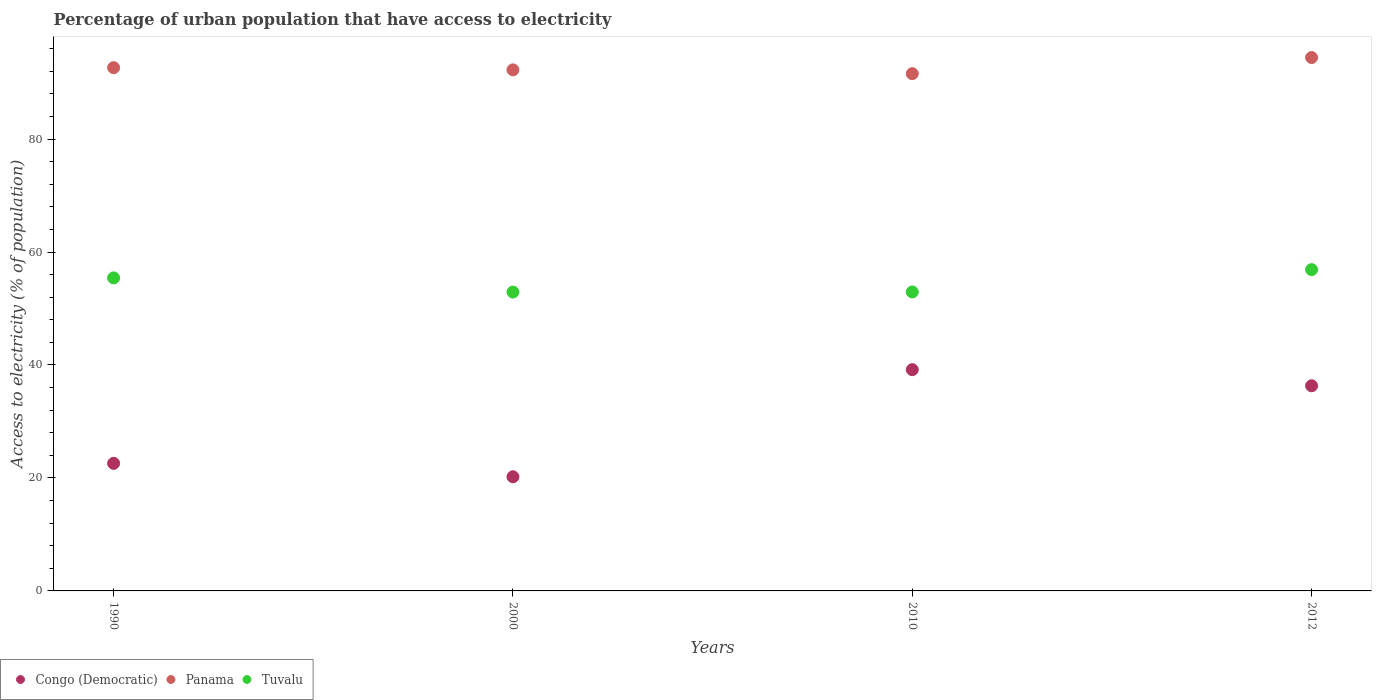What is the percentage of urban population that have access to electricity in Tuvalu in 2000?
Provide a short and direct response. 52.91. Across all years, what is the maximum percentage of urban population that have access to electricity in Congo (Democratic)?
Your response must be concise. 39.17. Across all years, what is the minimum percentage of urban population that have access to electricity in Tuvalu?
Offer a very short reply. 52.91. In which year was the percentage of urban population that have access to electricity in Tuvalu minimum?
Make the answer very short. 2000. What is the total percentage of urban population that have access to electricity in Tuvalu in the graph?
Your response must be concise. 218.14. What is the difference between the percentage of urban population that have access to electricity in Tuvalu in 1990 and that in 2000?
Keep it short and to the point. 2.51. What is the difference between the percentage of urban population that have access to electricity in Panama in 2000 and the percentage of urban population that have access to electricity in Congo (Democratic) in 2012?
Make the answer very short. 55.93. What is the average percentage of urban population that have access to electricity in Congo (Democratic) per year?
Offer a very short reply. 29.57. In the year 1990, what is the difference between the percentage of urban population that have access to electricity in Tuvalu and percentage of urban population that have access to electricity in Congo (Democratic)?
Your answer should be very brief. 32.84. What is the ratio of the percentage of urban population that have access to electricity in Panama in 1990 to that in 2000?
Your answer should be very brief. 1. What is the difference between the highest and the second highest percentage of urban population that have access to electricity in Congo (Democratic)?
Give a very brief answer. 2.86. What is the difference between the highest and the lowest percentage of urban population that have access to electricity in Panama?
Make the answer very short. 2.86. In how many years, is the percentage of urban population that have access to electricity in Tuvalu greater than the average percentage of urban population that have access to electricity in Tuvalu taken over all years?
Offer a very short reply. 2. Does the percentage of urban population that have access to electricity in Congo (Democratic) monotonically increase over the years?
Your answer should be very brief. No. How many dotlines are there?
Provide a succinct answer. 3. What is the difference between two consecutive major ticks on the Y-axis?
Give a very brief answer. 20. Are the values on the major ticks of Y-axis written in scientific E-notation?
Your response must be concise. No. Does the graph contain any zero values?
Make the answer very short. No. Where does the legend appear in the graph?
Provide a succinct answer. Bottom left. How many legend labels are there?
Offer a terse response. 3. How are the legend labels stacked?
Give a very brief answer. Horizontal. What is the title of the graph?
Make the answer very short. Percentage of urban population that have access to electricity. What is the label or title of the Y-axis?
Provide a succinct answer. Access to electricity (% of population). What is the Access to electricity (% of population) in Congo (Democratic) in 1990?
Your answer should be compact. 22.58. What is the Access to electricity (% of population) in Panama in 1990?
Make the answer very short. 92.63. What is the Access to electricity (% of population) in Tuvalu in 1990?
Your response must be concise. 55.42. What is the Access to electricity (% of population) of Congo (Democratic) in 2000?
Your response must be concise. 20.21. What is the Access to electricity (% of population) in Panama in 2000?
Provide a short and direct response. 92.25. What is the Access to electricity (% of population) of Tuvalu in 2000?
Offer a very short reply. 52.91. What is the Access to electricity (% of population) of Congo (Democratic) in 2010?
Provide a succinct answer. 39.17. What is the Access to electricity (% of population) of Panama in 2010?
Your answer should be compact. 91.57. What is the Access to electricity (% of population) of Tuvalu in 2010?
Offer a terse response. 52.93. What is the Access to electricity (% of population) of Congo (Democratic) in 2012?
Your response must be concise. 36.32. What is the Access to electricity (% of population) in Panama in 2012?
Provide a succinct answer. 94.43. What is the Access to electricity (% of population) in Tuvalu in 2012?
Provide a succinct answer. 56.88. Across all years, what is the maximum Access to electricity (% of population) in Congo (Democratic)?
Keep it short and to the point. 39.17. Across all years, what is the maximum Access to electricity (% of population) in Panama?
Ensure brevity in your answer.  94.43. Across all years, what is the maximum Access to electricity (% of population) in Tuvalu?
Give a very brief answer. 56.88. Across all years, what is the minimum Access to electricity (% of population) in Congo (Democratic)?
Offer a terse response. 20.21. Across all years, what is the minimum Access to electricity (% of population) in Panama?
Your answer should be compact. 91.57. Across all years, what is the minimum Access to electricity (% of population) in Tuvalu?
Provide a succinct answer. 52.91. What is the total Access to electricity (% of population) of Congo (Democratic) in the graph?
Provide a succinct answer. 118.29. What is the total Access to electricity (% of population) in Panama in the graph?
Your response must be concise. 370.88. What is the total Access to electricity (% of population) in Tuvalu in the graph?
Ensure brevity in your answer.  218.14. What is the difference between the Access to electricity (% of population) in Congo (Democratic) in 1990 and that in 2000?
Make the answer very short. 2.37. What is the difference between the Access to electricity (% of population) in Panama in 1990 and that in 2000?
Make the answer very short. 0.39. What is the difference between the Access to electricity (% of population) of Tuvalu in 1990 and that in 2000?
Make the answer very short. 2.51. What is the difference between the Access to electricity (% of population) in Congo (Democratic) in 1990 and that in 2010?
Provide a short and direct response. -16.59. What is the difference between the Access to electricity (% of population) in Panama in 1990 and that in 2010?
Your answer should be very brief. 1.06. What is the difference between the Access to electricity (% of population) in Tuvalu in 1990 and that in 2010?
Provide a short and direct response. 2.49. What is the difference between the Access to electricity (% of population) of Congo (Democratic) in 1990 and that in 2012?
Provide a short and direct response. -13.73. What is the difference between the Access to electricity (% of population) in Panama in 1990 and that in 2012?
Provide a short and direct response. -1.8. What is the difference between the Access to electricity (% of population) of Tuvalu in 1990 and that in 2012?
Make the answer very short. -1.46. What is the difference between the Access to electricity (% of population) of Congo (Democratic) in 2000 and that in 2010?
Your answer should be compact. -18.96. What is the difference between the Access to electricity (% of population) of Panama in 2000 and that in 2010?
Make the answer very short. 0.67. What is the difference between the Access to electricity (% of population) of Tuvalu in 2000 and that in 2010?
Offer a very short reply. -0.02. What is the difference between the Access to electricity (% of population) of Congo (Democratic) in 2000 and that in 2012?
Keep it short and to the point. -16.11. What is the difference between the Access to electricity (% of population) of Panama in 2000 and that in 2012?
Make the answer very short. -2.18. What is the difference between the Access to electricity (% of population) in Tuvalu in 2000 and that in 2012?
Keep it short and to the point. -3.97. What is the difference between the Access to electricity (% of population) of Congo (Democratic) in 2010 and that in 2012?
Your response must be concise. 2.86. What is the difference between the Access to electricity (% of population) of Panama in 2010 and that in 2012?
Offer a terse response. -2.86. What is the difference between the Access to electricity (% of population) in Tuvalu in 2010 and that in 2012?
Offer a very short reply. -3.95. What is the difference between the Access to electricity (% of population) of Congo (Democratic) in 1990 and the Access to electricity (% of population) of Panama in 2000?
Your answer should be very brief. -69.66. What is the difference between the Access to electricity (% of population) in Congo (Democratic) in 1990 and the Access to electricity (% of population) in Tuvalu in 2000?
Your response must be concise. -30.33. What is the difference between the Access to electricity (% of population) in Panama in 1990 and the Access to electricity (% of population) in Tuvalu in 2000?
Your response must be concise. 39.72. What is the difference between the Access to electricity (% of population) in Congo (Democratic) in 1990 and the Access to electricity (% of population) in Panama in 2010?
Your response must be concise. -68.99. What is the difference between the Access to electricity (% of population) in Congo (Democratic) in 1990 and the Access to electricity (% of population) in Tuvalu in 2010?
Give a very brief answer. -30.35. What is the difference between the Access to electricity (% of population) of Panama in 1990 and the Access to electricity (% of population) of Tuvalu in 2010?
Offer a terse response. 39.7. What is the difference between the Access to electricity (% of population) in Congo (Democratic) in 1990 and the Access to electricity (% of population) in Panama in 2012?
Provide a succinct answer. -71.85. What is the difference between the Access to electricity (% of population) of Congo (Democratic) in 1990 and the Access to electricity (% of population) of Tuvalu in 2012?
Offer a terse response. -34.3. What is the difference between the Access to electricity (% of population) of Panama in 1990 and the Access to electricity (% of population) of Tuvalu in 2012?
Your response must be concise. 35.75. What is the difference between the Access to electricity (% of population) of Congo (Democratic) in 2000 and the Access to electricity (% of population) of Panama in 2010?
Give a very brief answer. -71.36. What is the difference between the Access to electricity (% of population) of Congo (Democratic) in 2000 and the Access to electricity (% of population) of Tuvalu in 2010?
Keep it short and to the point. -32.72. What is the difference between the Access to electricity (% of population) in Panama in 2000 and the Access to electricity (% of population) in Tuvalu in 2010?
Offer a very short reply. 39.32. What is the difference between the Access to electricity (% of population) in Congo (Democratic) in 2000 and the Access to electricity (% of population) in Panama in 2012?
Your answer should be very brief. -74.22. What is the difference between the Access to electricity (% of population) in Congo (Democratic) in 2000 and the Access to electricity (% of population) in Tuvalu in 2012?
Give a very brief answer. -36.67. What is the difference between the Access to electricity (% of population) in Panama in 2000 and the Access to electricity (% of population) in Tuvalu in 2012?
Your answer should be compact. 35.37. What is the difference between the Access to electricity (% of population) in Congo (Democratic) in 2010 and the Access to electricity (% of population) in Panama in 2012?
Keep it short and to the point. -55.26. What is the difference between the Access to electricity (% of population) of Congo (Democratic) in 2010 and the Access to electricity (% of population) of Tuvalu in 2012?
Make the answer very short. -17.71. What is the difference between the Access to electricity (% of population) of Panama in 2010 and the Access to electricity (% of population) of Tuvalu in 2012?
Provide a short and direct response. 34.69. What is the average Access to electricity (% of population) in Congo (Democratic) per year?
Your answer should be very brief. 29.57. What is the average Access to electricity (% of population) of Panama per year?
Provide a short and direct response. 92.72. What is the average Access to electricity (% of population) in Tuvalu per year?
Ensure brevity in your answer.  54.54. In the year 1990, what is the difference between the Access to electricity (% of population) of Congo (Democratic) and Access to electricity (% of population) of Panama?
Offer a terse response. -70.05. In the year 1990, what is the difference between the Access to electricity (% of population) of Congo (Democratic) and Access to electricity (% of population) of Tuvalu?
Ensure brevity in your answer.  -32.84. In the year 1990, what is the difference between the Access to electricity (% of population) of Panama and Access to electricity (% of population) of Tuvalu?
Make the answer very short. 37.21. In the year 2000, what is the difference between the Access to electricity (% of population) in Congo (Democratic) and Access to electricity (% of population) in Panama?
Offer a terse response. -72.04. In the year 2000, what is the difference between the Access to electricity (% of population) of Congo (Democratic) and Access to electricity (% of population) of Tuvalu?
Ensure brevity in your answer.  -32.7. In the year 2000, what is the difference between the Access to electricity (% of population) of Panama and Access to electricity (% of population) of Tuvalu?
Ensure brevity in your answer.  39.34. In the year 2010, what is the difference between the Access to electricity (% of population) of Congo (Democratic) and Access to electricity (% of population) of Panama?
Provide a short and direct response. -52.4. In the year 2010, what is the difference between the Access to electricity (% of population) of Congo (Democratic) and Access to electricity (% of population) of Tuvalu?
Offer a very short reply. -13.76. In the year 2010, what is the difference between the Access to electricity (% of population) of Panama and Access to electricity (% of population) of Tuvalu?
Provide a short and direct response. 38.64. In the year 2012, what is the difference between the Access to electricity (% of population) of Congo (Democratic) and Access to electricity (% of population) of Panama?
Ensure brevity in your answer.  -58.11. In the year 2012, what is the difference between the Access to electricity (% of population) in Congo (Democratic) and Access to electricity (% of population) in Tuvalu?
Offer a very short reply. -20.56. In the year 2012, what is the difference between the Access to electricity (% of population) of Panama and Access to electricity (% of population) of Tuvalu?
Your answer should be compact. 37.55. What is the ratio of the Access to electricity (% of population) in Congo (Democratic) in 1990 to that in 2000?
Keep it short and to the point. 1.12. What is the ratio of the Access to electricity (% of population) of Panama in 1990 to that in 2000?
Your answer should be very brief. 1. What is the ratio of the Access to electricity (% of population) of Tuvalu in 1990 to that in 2000?
Make the answer very short. 1.05. What is the ratio of the Access to electricity (% of population) of Congo (Democratic) in 1990 to that in 2010?
Your answer should be very brief. 0.58. What is the ratio of the Access to electricity (% of population) in Panama in 1990 to that in 2010?
Provide a short and direct response. 1.01. What is the ratio of the Access to electricity (% of population) in Tuvalu in 1990 to that in 2010?
Your response must be concise. 1.05. What is the ratio of the Access to electricity (% of population) of Congo (Democratic) in 1990 to that in 2012?
Your answer should be compact. 0.62. What is the ratio of the Access to electricity (% of population) of Panama in 1990 to that in 2012?
Give a very brief answer. 0.98. What is the ratio of the Access to electricity (% of population) in Tuvalu in 1990 to that in 2012?
Give a very brief answer. 0.97. What is the ratio of the Access to electricity (% of population) of Congo (Democratic) in 2000 to that in 2010?
Your response must be concise. 0.52. What is the ratio of the Access to electricity (% of population) of Panama in 2000 to that in 2010?
Provide a succinct answer. 1.01. What is the ratio of the Access to electricity (% of population) in Tuvalu in 2000 to that in 2010?
Provide a short and direct response. 1. What is the ratio of the Access to electricity (% of population) of Congo (Democratic) in 2000 to that in 2012?
Provide a succinct answer. 0.56. What is the ratio of the Access to electricity (% of population) in Panama in 2000 to that in 2012?
Your answer should be very brief. 0.98. What is the ratio of the Access to electricity (% of population) of Tuvalu in 2000 to that in 2012?
Provide a succinct answer. 0.93. What is the ratio of the Access to electricity (% of population) in Congo (Democratic) in 2010 to that in 2012?
Your answer should be compact. 1.08. What is the ratio of the Access to electricity (% of population) in Panama in 2010 to that in 2012?
Your answer should be compact. 0.97. What is the ratio of the Access to electricity (% of population) in Tuvalu in 2010 to that in 2012?
Your response must be concise. 0.93. What is the difference between the highest and the second highest Access to electricity (% of population) in Congo (Democratic)?
Your response must be concise. 2.86. What is the difference between the highest and the second highest Access to electricity (% of population) of Panama?
Give a very brief answer. 1.8. What is the difference between the highest and the second highest Access to electricity (% of population) of Tuvalu?
Provide a short and direct response. 1.46. What is the difference between the highest and the lowest Access to electricity (% of population) in Congo (Democratic)?
Give a very brief answer. 18.96. What is the difference between the highest and the lowest Access to electricity (% of population) in Panama?
Make the answer very short. 2.86. What is the difference between the highest and the lowest Access to electricity (% of population) in Tuvalu?
Offer a very short reply. 3.97. 